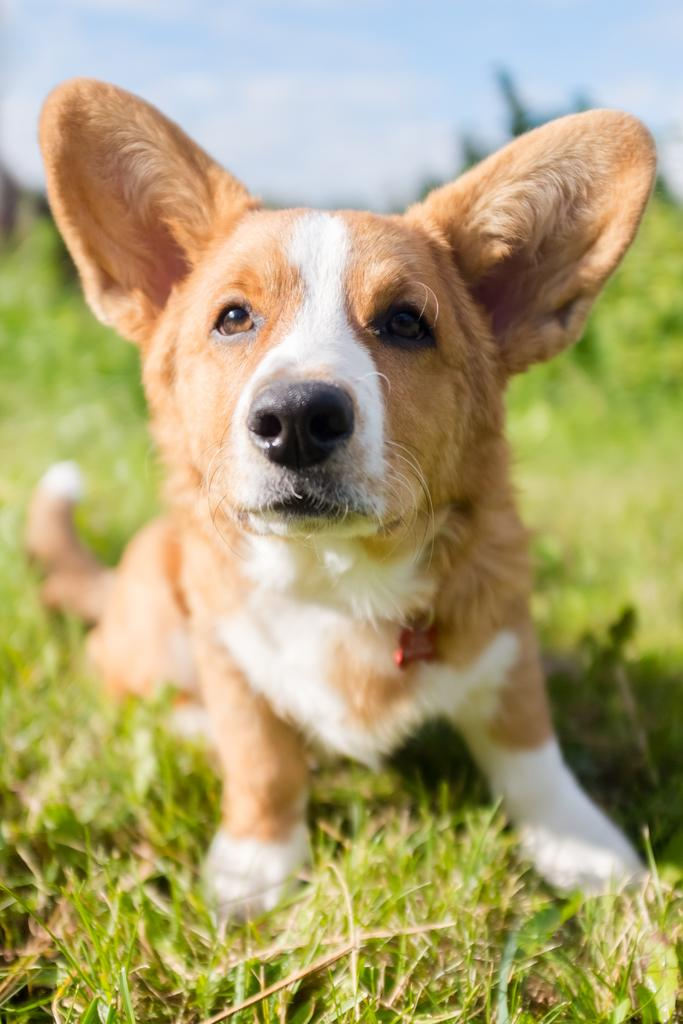What animal can be seen in the image? There is a dog in the image. Where is the dog located? The dog is on the grass. What can be seen in the background of the image? There is sky visible in the background of the image. What is the aftermath of the rain in the image? There is no mention of rain in the image, so it is not possible to determine the aftermath of any rain. 